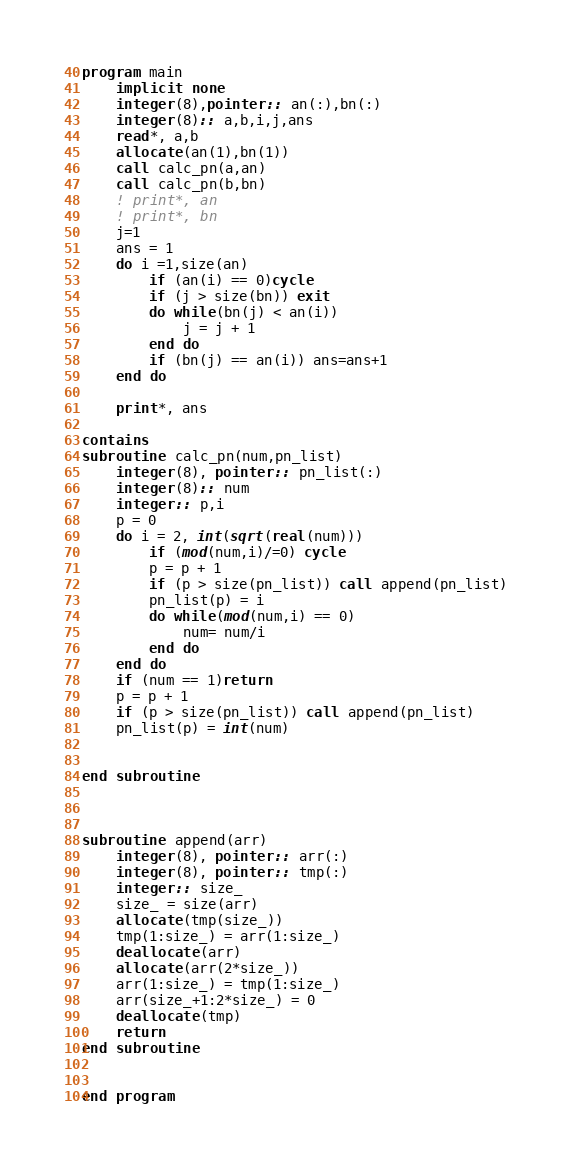Convert code to text. <code><loc_0><loc_0><loc_500><loc_500><_FORTRAN_>program main
    implicit none
    integer(8),pointer:: an(:),bn(:)
    integer(8):: a,b,i,j,ans
    read*, a,b
    allocate(an(1),bn(1))
    call calc_pn(a,an)
    call calc_pn(b,bn)
    ! print*, an
    ! print*, bn
    j=1
    ans = 1
    do i =1,size(an)
        if (an(i) == 0)cycle
        if (j > size(bn)) exit
        do while(bn(j) < an(i))
            j = j + 1
        end do
        if (bn(j) == an(i)) ans=ans+1
    end do

    print*, ans

contains
subroutine calc_pn(num,pn_list)
    integer(8), pointer:: pn_list(:)
    integer(8):: num
    integer:: p,i
    p = 0
    do i = 2, int(sqrt(real(num)))
        if (mod(num,i)/=0) cycle
        p = p + 1
        if (p > size(pn_list)) call append(pn_list)
        pn_list(p) = i
        do while(mod(num,i) == 0)
            num= num/i
        end do
    end do
    if (num == 1)return
    p = p + 1
    if (p > size(pn_list)) call append(pn_list)
    pn_list(p) = int(num)
    
    
end subroutine 



subroutine append(arr) 
    integer(8), pointer:: arr(:)
    integer(8), pointer:: tmp(:)
    integer:: size_
    size_ = size(arr)
    allocate(tmp(size_))
    tmp(1:size_) = arr(1:size_)
    deallocate(arr)
    allocate(arr(2*size_))
    arr(1:size_) = tmp(1:size_)
    arr(size_+1:2*size_) = 0
    deallocate(tmp)
    return
end subroutine


end program</code> 